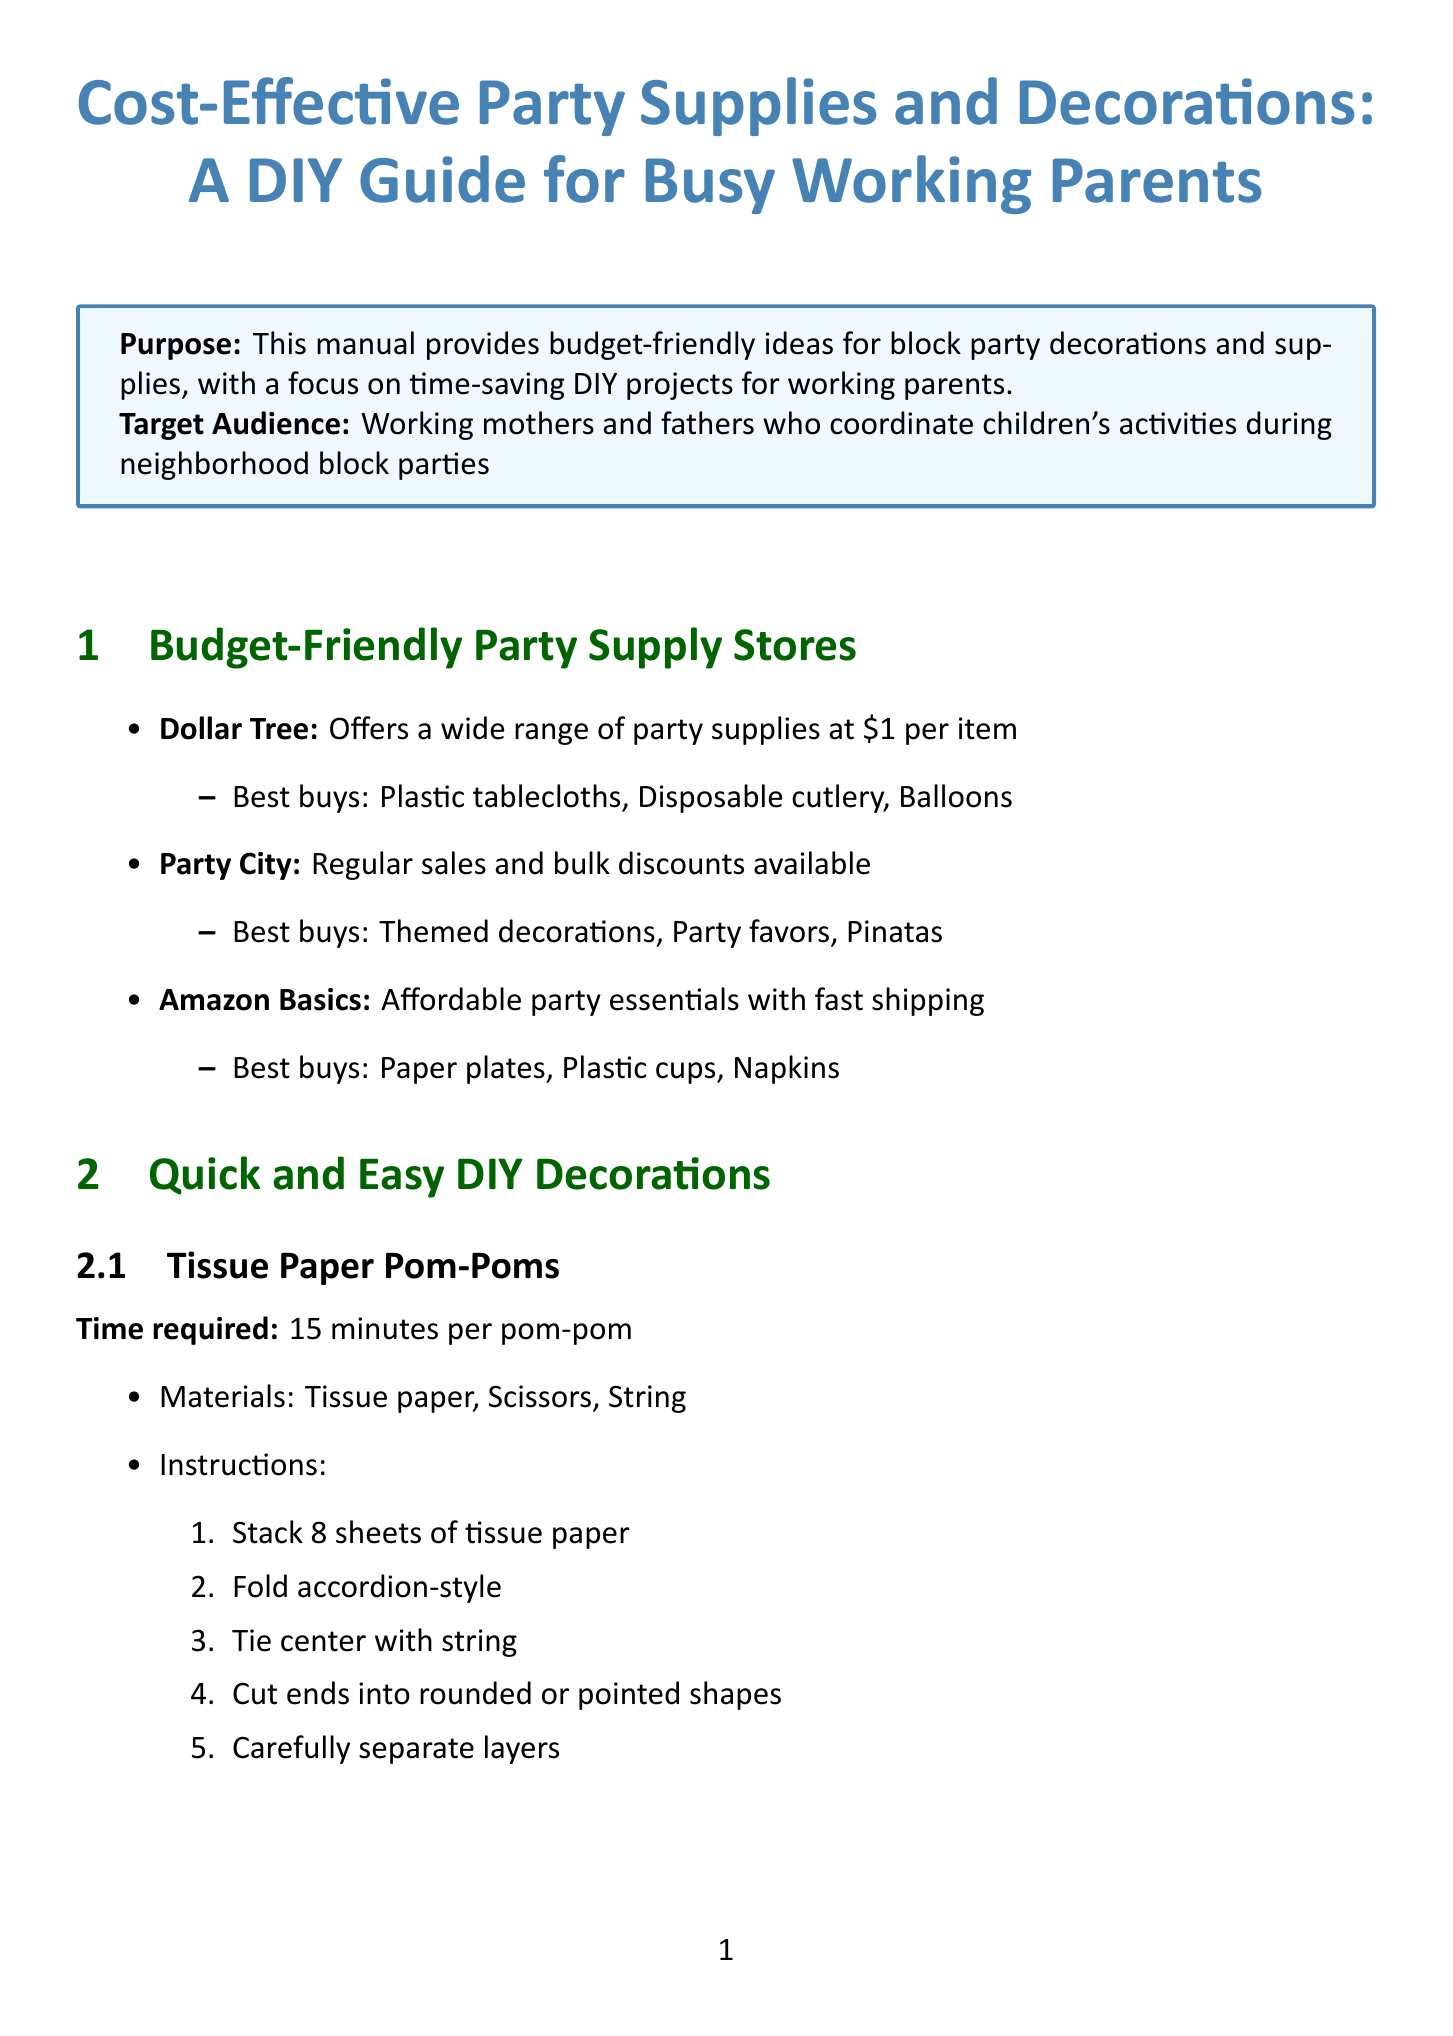What is the purpose of the manual? The purpose of the manual is to provide budget-friendly ideas for block party decorations and supplies, with a focus on time-saving DIY projects for working parents.
Answer: budget-friendly ideas for block party decorations and supplies What is the name of the first store listed under budget-friendly party supply stores? The first store listed is Dollar Tree, which is noted for its wide range of party supplies at a low price.
Answer: Dollar Tree How long does it take to make a Tissue Paper Pom-Pom? The time required to make a Tissue Paper Pom-Pom is specified as 15 minutes per pom-pom.
Answer: 15 minutes What is the approximate cost of Paper Straws from Aardvark? The approximate cost for Paper Straws from Aardvark is listed in the document.
Answer: $8 for 100 straws What age range is recommended for the Bubble Station activity? The recommended age range for the Bubble Station activity is specified in the document.
Answer: All ages Which food idea requires 10 minutes of prep time? The food idea that requires 10 minutes of prep time is Slow Cooker BBQ Pulled Pork.
Answer: Slow Cooker BBQ Pulled Pork Which DIY project takes 30 minutes plus drying time? The DIY project that takes 30 minutes (plus drying time) is Painted Mason Jar Centerpieces.
Answer: Painted Mason Jar Centerpieces What is one of the final tips given in the conclusion? One of the final tips given is to delegate tasks to other parents or older children.
Answer: Delegate tasks to other parents or older children 